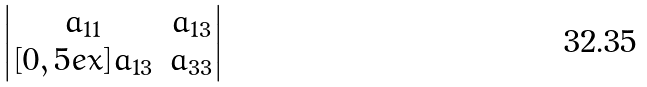Convert formula to latex. <formula><loc_0><loc_0><loc_500><loc_500>\begin{vmatrix} a _ { 1 1 } & a _ { 1 3 } \\ [ 0 , 5 e x ] a _ { 1 3 } & a _ { 3 3 } \end{vmatrix}</formula> 